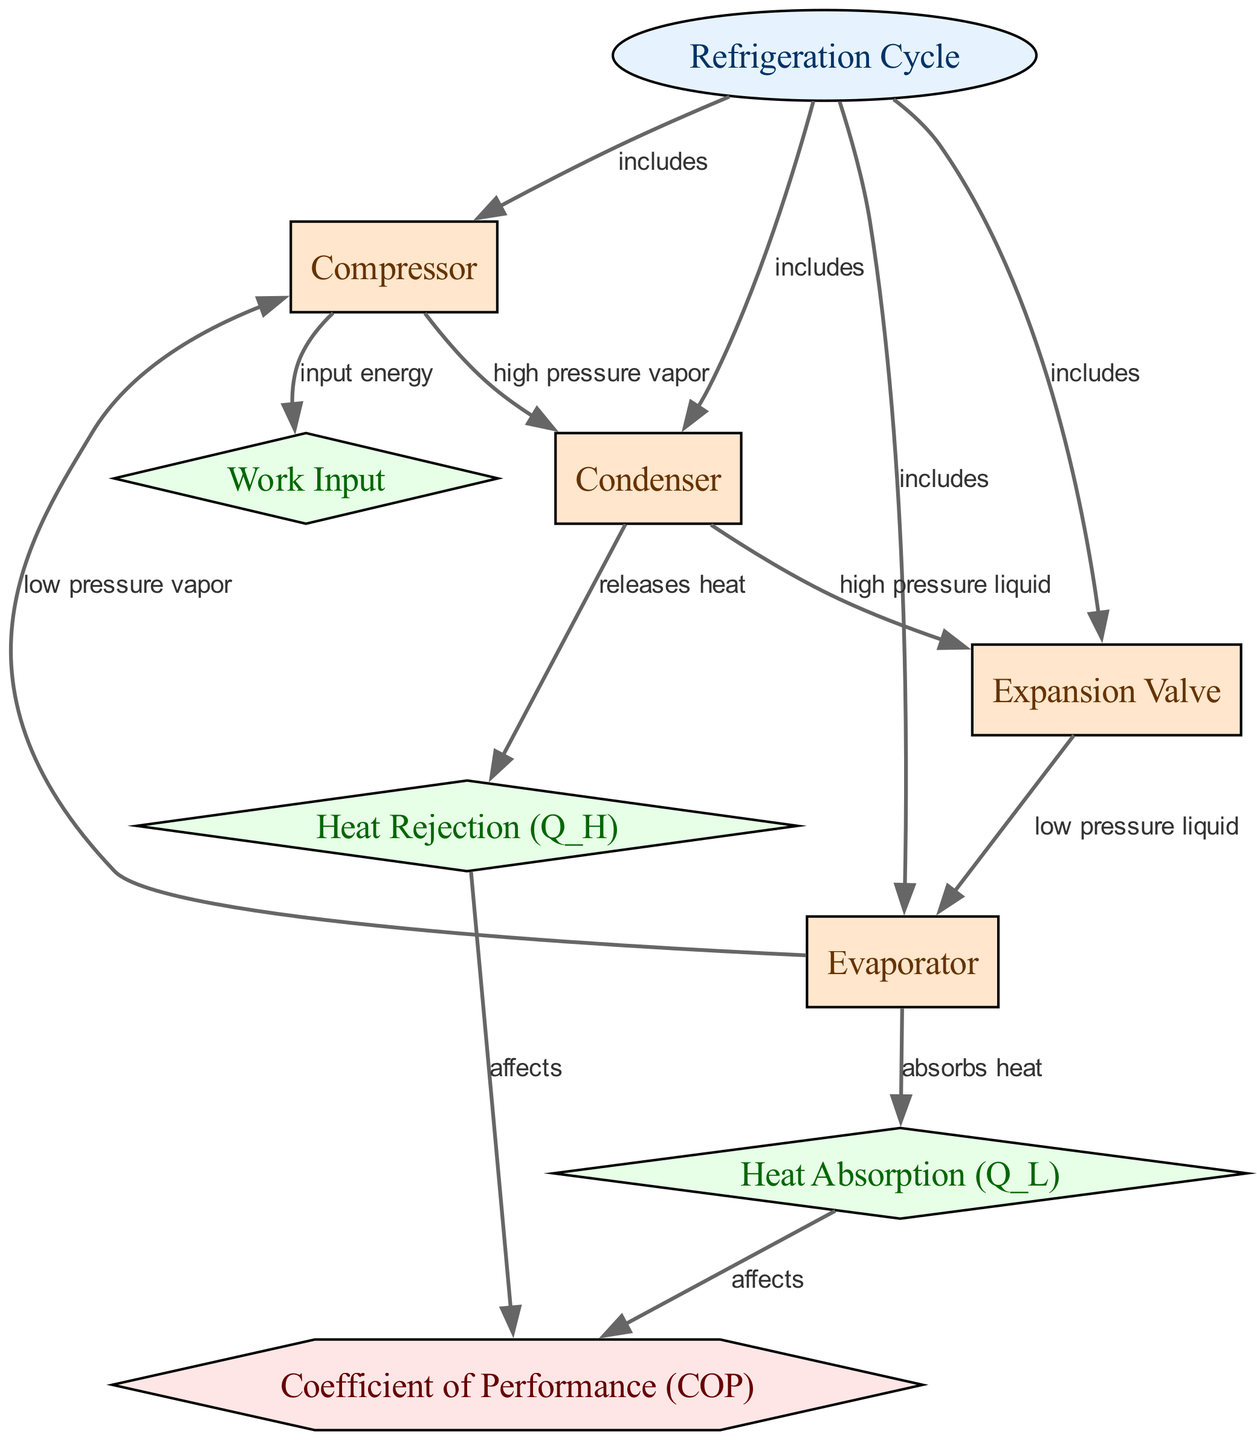What is the Coefficient of Performance (COP) associated with the refrigeration cycle? The Coefficient of Performance is represented as a metric in the diagram, connected to both heat rejection (Q_H) and heat absorption (Q_L), indicating its dependence on these processes.
Answer: Coefficient of Performance (COP) How many components are included in the refrigeration cycle? The diagram specifically indicates four components: Compressor, Condenser, Expansion Valve, and Evaporator, all of which are connected to the central node of the refrigeration cycle.
Answer: Four What type of process occurs at the Expansion Valve? The Expansion Valve connects to the Evaporator through "low pressure liquid," indicating the process type transitioned through this component.
Answer: Low pressure liquid What process does the Condenser perform? The Condenser is linked to the "releases heat" process, showing its function within the refrigeration cycle and emphasizing the role of heat rejection.
Answer: Releases heat Which component receives input energy? The diagram shows a direct connection from the Compressor to "input energy," indicating that this component is responsible for work input in the refrigeration cycle.
Answer: Compressor What two processes affect the Coefficient of Performance (COP)? The Coefficient of Performance is affected by heat rejection (Q_H) and heat absorption (Q_L), as indicated by the directed edges leading from these processes to the metric node in the diagram.
Answer: Heat rejection (Q_H) and Heat absorption (Q_L) What is the state of the fluid after it leaves the Evaporator? The diagram connects the Evaporator back to the Compressor, labeled as "low pressure vapor," indicating the state of the fluid post-Evaporator.
Answer: Low pressure vapor Which component is the starting point for heat absorption in the refrigeration cycle? The Evaporator is identified as the starting point for the heat absorption process, as it is directly connected to this process in the diagram and initiates the refrigeration actions.
Answer: Evaporator 